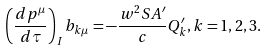<formula> <loc_0><loc_0><loc_500><loc_500>\left ( \frac { d p ^ { \mu } } { d \tau } \right ) _ { I } b _ { k \mu } = - \frac { w ^ { 2 } S A ^ { \prime } } { c } Q ^ { \prime } _ { k } , k = 1 , 2 , 3 .</formula> 